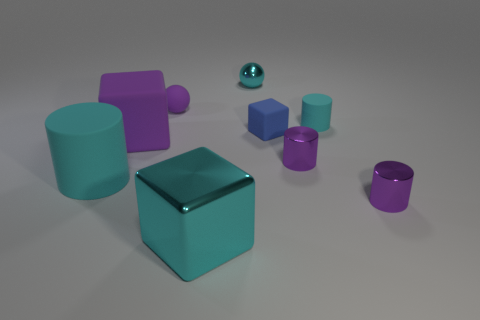Subtract all large cylinders. How many cylinders are left? 3 Subtract all red cylinders. Subtract all gray blocks. How many cylinders are left? 4 Add 1 tiny blue rubber objects. How many objects exist? 10 Subtract all spheres. How many objects are left? 7 Add 3 shiny spheres. How many shiny spheres exist? 4 Subtract 0 green blocks. How many objects are left? 9 Subtract all large purple things. Subtract all small things. How many objects are left? 2 Add 6 large rubber cylinders. How many large rubber cylinders are left? 7 